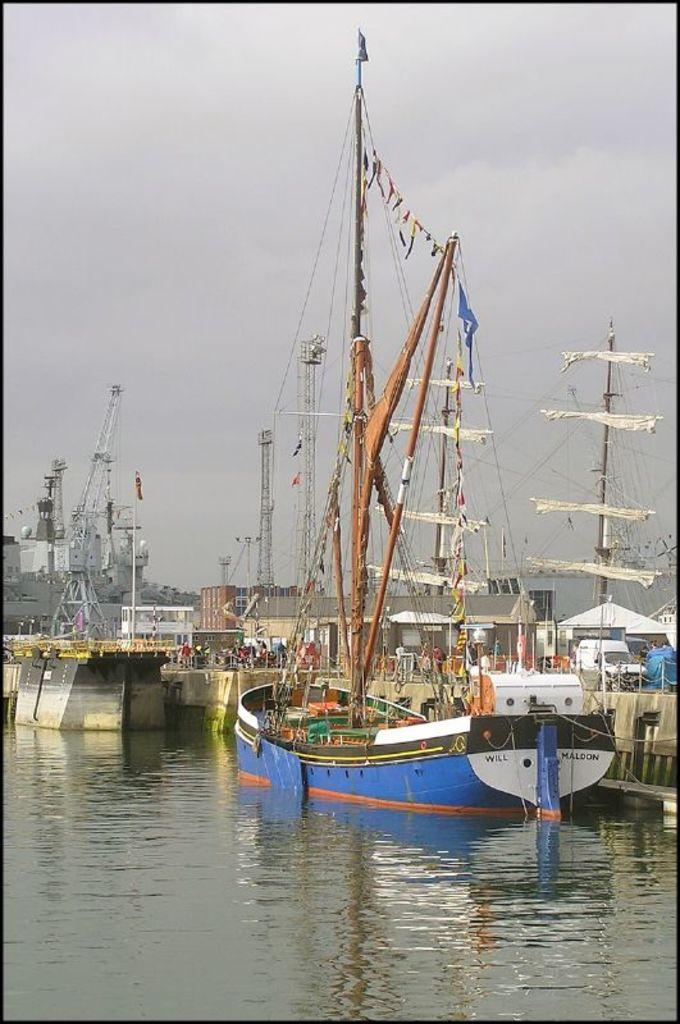What is the main subject of the image? The image depicts a ship harbor. How many ships can be seen in the water? There are multiple ships in the water. What can be seen in the background of the image? There are cranes in the background. What is visible at the top of the image? The sky is visible at the top of the image. What type of nerve can be seen in the image? There is no nerve present in the image; it features a ship harbor with multiple ships in the water and cranes in the background. What material is the picture made of? The question is unclear, as the image itself is not a physical object. However, if referring to the medium of the image (e.g., a photograph or digital file), it is not made of any specific material. 